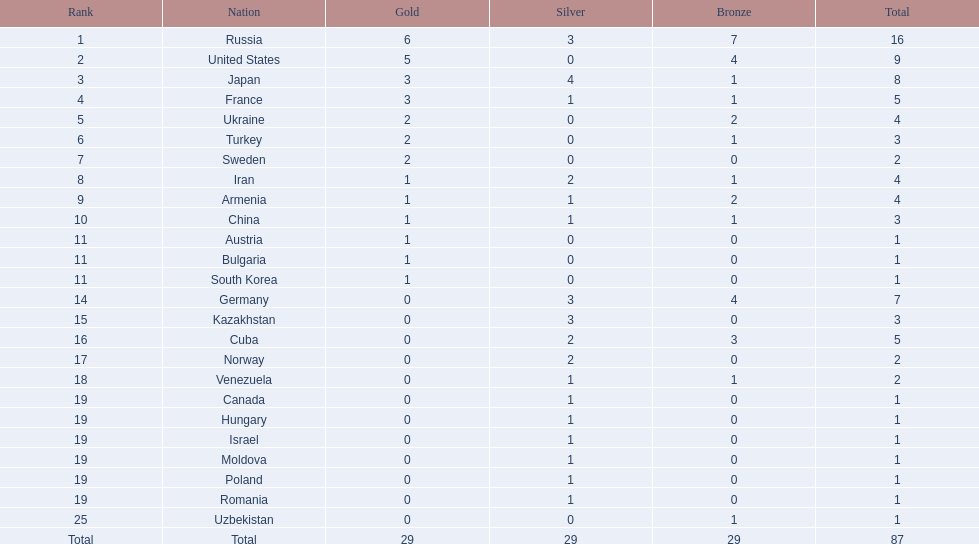Which nations participated in the 1995 world wrestling championships? Russia, United States, Japan, France, Ukraine, Turkey, Sweden, Iran, Armenia, China, Austria, Bulgaria, South Korea, Germany, Kazakhstan, Cuba, Norway, Venezuela, Canada, Hungary, Israel, Moldova, Poland, Romania, Uzbekistan. And between iran and germany, which one placed in the top 10? Germany. 